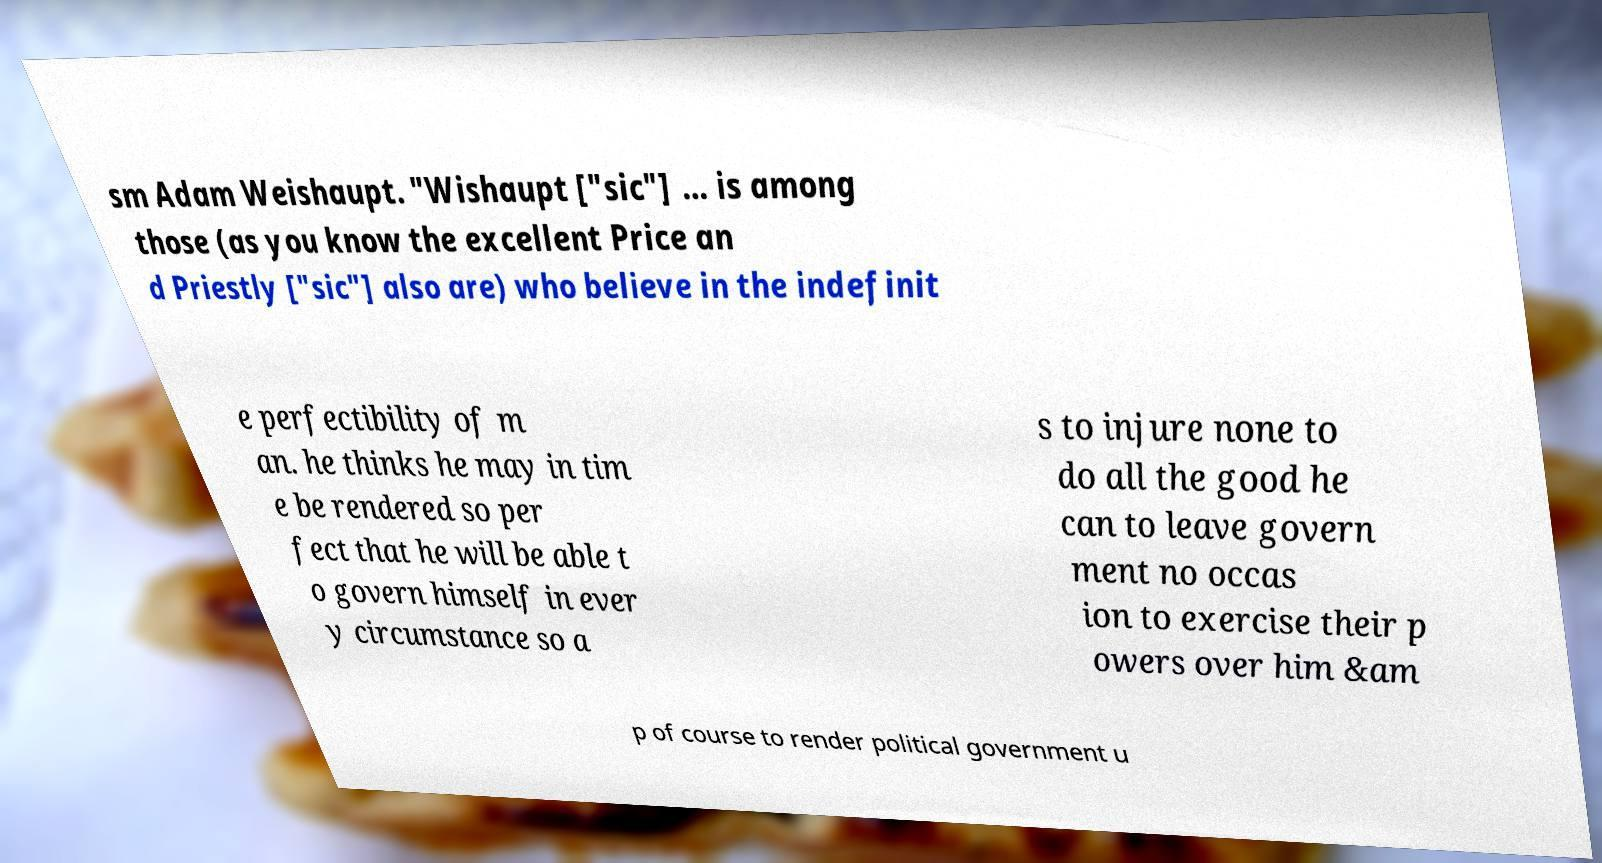Please read and relay the text visible in this image. What does it say? sm Adam Weishaupt. "Wishaupt ["sic"] … is among those (as you know the excellent Price an d Priestly ["sic"] also are) who believe in the indefinit e perfectibility of m an. he thinks he may in tim e be rendered so per fect that he will be able t o govern himself in ever y circumstance so a s to injure none to do all the good he can to leave govern ment no occas ion to exercise their p owers over him &am p of course to render political government u 